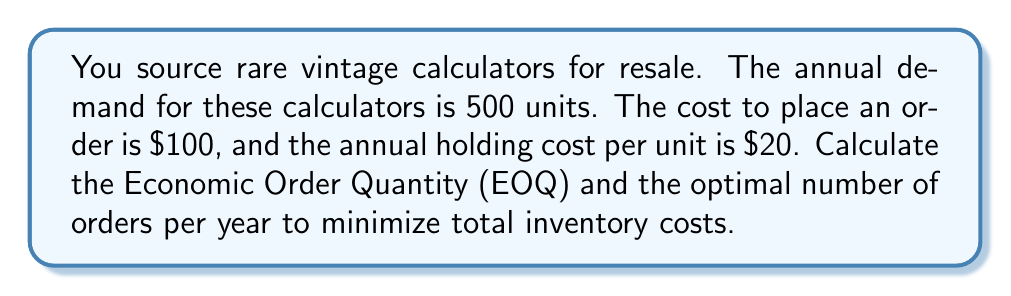Help me with this question. To solve this problem, we'll use the Economic Order Quantity (EOQ) formula and follow these steps:

1. Identify the variables:
   $D$ = Annual demand = 500 units
   $K$ = Cost per order = $100
   $h$ = Annual holding cost per unit = $20

2. Apply the EOQ formula:
   $$EOQ = \sqrt{\frac{2KD}{h}}$$

3. Substitute the values:
   $$EOQ = \sqrt{\frac{2 \cdot 100 \cdot 500}{20}}$$

4. Simplify:
   $$EOQ = \sqrt{\frac{100,000}{20}} = \sqrt{5000} \approx 70.71$$

5. Round to the nearest whole number:
   EOQ = 71 units

6. Calculate the optimal number of orders per year:
   $$\text{Number of orders} = \frac{\text{Annual demand}}{\text{EOQ}}$$
   $$\text{Number of orders} = \frac{500}{71} \approx 7.04$$

7. Round to the nearest whole number:
   Optimal number of orders = 7 orders per year
Answer: EOQ: 71 units; Optimal orders per year: 7 